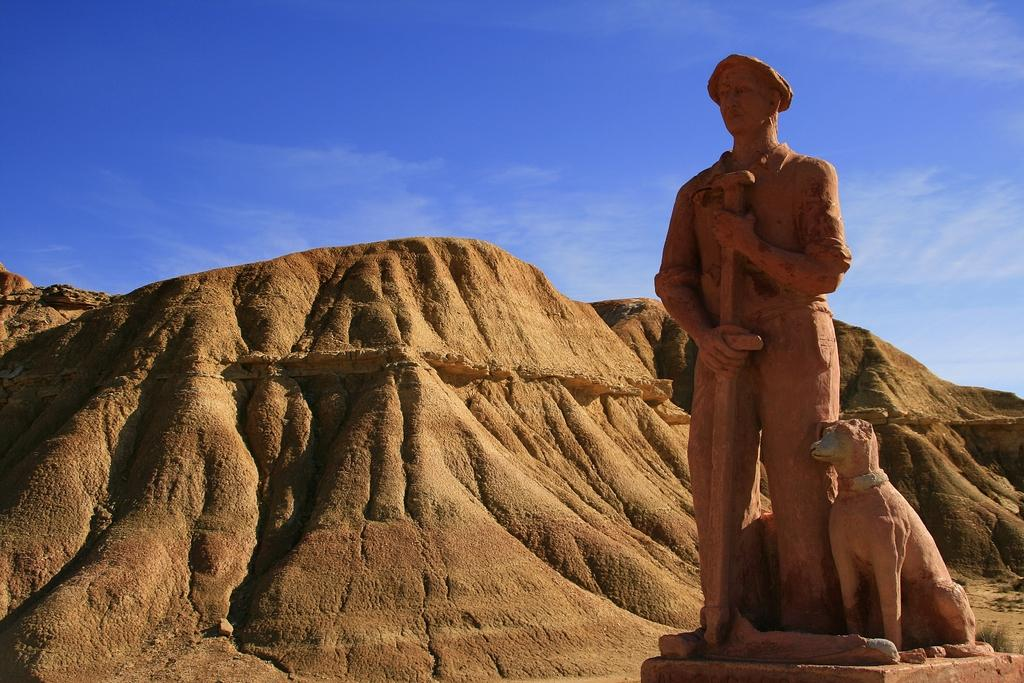What type of statues are present in the image? There is a statue of a person and a statue of a dog in the image. What can be seen in the background of the image? There are mountains, clouds, and a blue sky in the background of the image. How many mice are sitting on the person's hat in the image? There are no mice or hats present in the image. What type of pies can be seen in the image? There are no pies present in the image. 